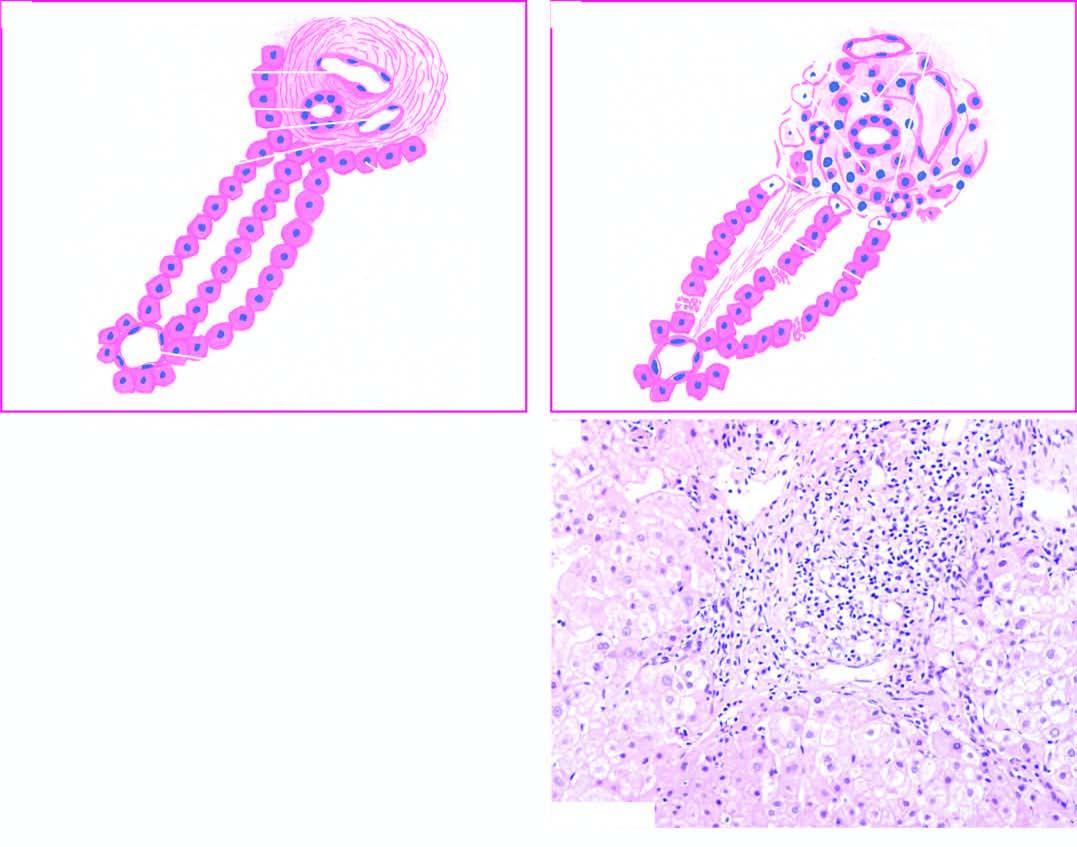re hepatocytes at the interface of portal tract and lobule destroyed?
Answer the question using a single word or phrase. Yes 